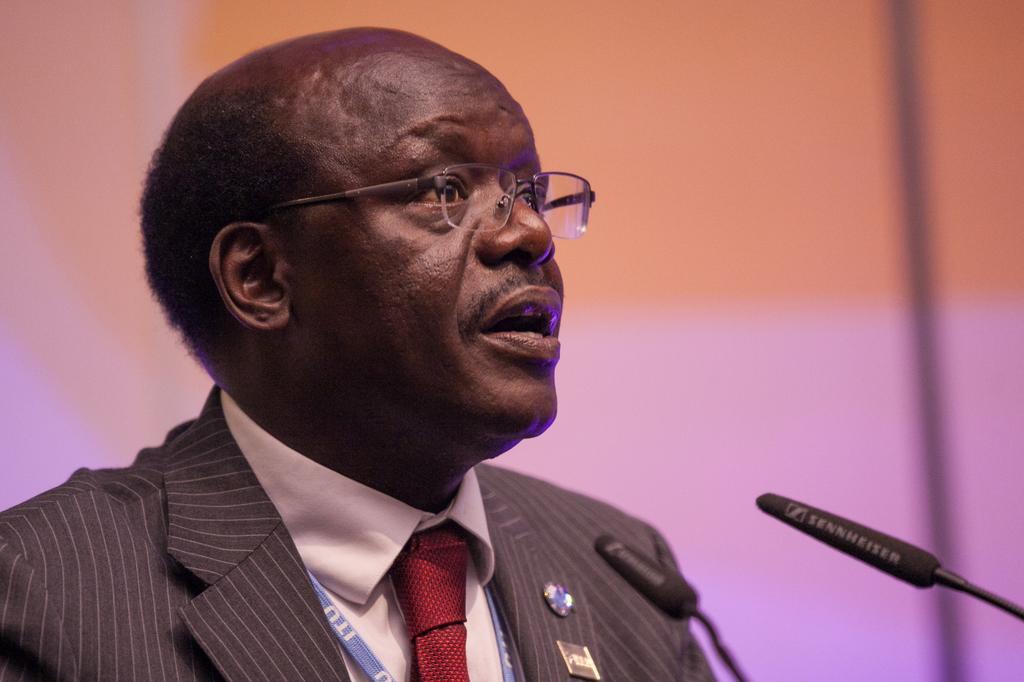Could you give a brief overview of what you see in this image? In this image we can see a man wearing suit. There are mics. In the background there is a wall. 